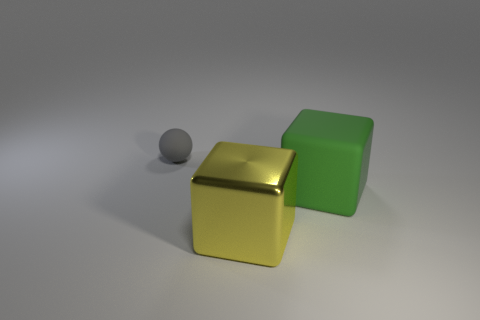Add 2 small things. How many objects exist? 5 Subtract all blocks. How many objects are left? 1 Subtract 1 green blocks. How many objects are left? 2 Subtract all small matte balls. Subtract all gray matte things. How many objects are left? 1 Add 1 tiny rubber objects. How many tiny rubber objects are left? 2 Add 1 yellow metallic things. How many yellow metallic things exist? 2 